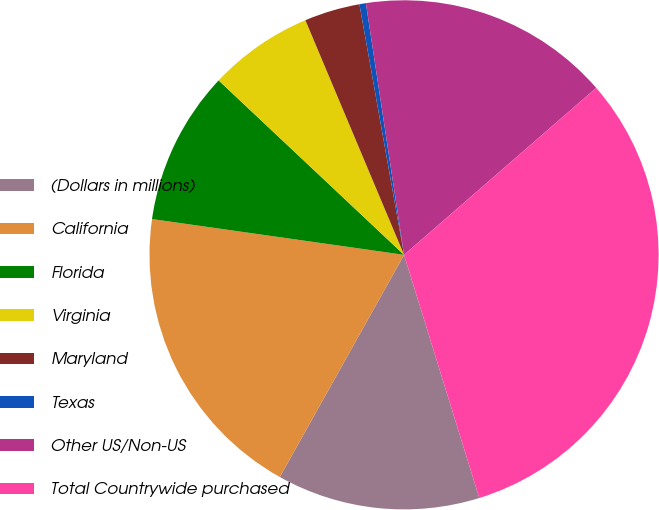<chart> <loc_0><loc_0><loc_500><loc_500><pie_chart><fcel>(Dollars in millions)<fcel>California<fcel>Florida<fcel>Virginia<fcel>Maryland<fcel>Texas<fcel>Other US/Non-US<fcel>Total Countrywide purchased<nl><fcel>12.89%<fcel>19.13%<fcel>9.77%<fcel>6.65%<fcel>3.53%<fcel>0.41%<fcel>16.01%<fcel>31.61%<nl></chart> 